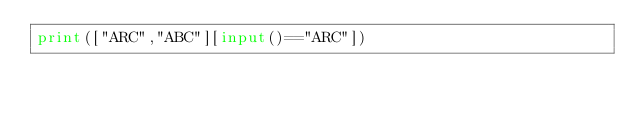Convert code to text. <code><loc_0><loc_0><loc_500><loc_500><_Python_>print(["ARC","ABC"][input()=="ARC"])</code> 